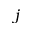<formula> <loc_0><loc_0><loc_500><loc_500>j</formula> 